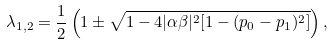Convert formula to latex. <formula><loc_0><loc_0><loc_500><loc_500>\lambda _ { 1 , 2 } = \frac { 1 } { 2 } \left ( 1 \pm \sqrt { 1 - 4 | \alpha \beta | ^ { 2 } [ 1 - ( p _ { 0 } - p _ { 1 } ) ^ { 2 } ] } \right ) ,</formula> 